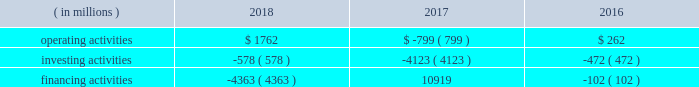Bhge 2018 form 10-k | 39 outstanding under the commercial paper program .
The maximum combined borrowing at any time under both the 2017 credit agreement and the commercial paper program is $ 3 billion .
If market conditions were to change and our revenue was reduced significantly or operating costs were to increase , our cash flows and liquidity could be reduced .
Additionally , it could cause the rating agencies to lower our credit rating .
There are no ratings triggers that would accelerate the maturity of any borrowings under our committed credit facility .
However , a downgrade in our credit ratings could increase the cost of borrowings under the credit facility and could also limit or preclude our ability to issue commercial paper .
Should this occur , we could seek alternative sources of funding , including borrowing under the credit facility .
During the year ended december 31 , 2018 , we used cash to fund a variety of activities including certain working capital needs and restructuring costs , capital expenditures , the repayment of debt , payment of dividends , distributions to ge and share repurchases .
We believe that cash on hand , cash flows generated from operations and the available credit facility will provide sufficient liquidity to manage our global cash needs .
Cash flows cash flows provided by ( used in ) each type of activity were as follows for the years ended december 31: .
Operating activities our largest source of operating cash is payments from customers , of which the largest component is collecting cash related to product or services sales including advance payments or progress collections for work to be performed .
The primary use of operating cash is to pay our suppliers , employees , tax authorities and others for a wide range of material and services .
Cash flows from operating activities generated cash of $ 1762 million and used cash of $ 799 million for the years ended december 31 , 2018 and 2017 , respectively .
Cash flows from operating activities increased $ 2561 million in 2018 primarily driven by better operating performance .
These cash inflows were supported by strong working capital cash flows , especially in the fourth quarter of 2018 , including approximately $ 300 million for a progress collection payment from a customer .
Included in our cash flows from operating activities for 2018 and 2017 are payments of $ 473 million and $ 612 million , respectively , made primarily for employee severance as a result of our restructuring activities and merger and related costs .
Cash flows from operating activities used $ 799 million and generated $ 262 million for the years ended december 31 , 2017 and 2016 , respectively .
Cash flows from operating activities decreased $ 1061 million in 2017 primarily driven by a $ 1201 million negative impact from ending our receivables monetization program in the fourth quarter , and restructuring related payments throughout the year .
These cash outflows were partially offset by strong working capital cash flows , especially in the fourth quarter of 2017 .
Included in our cash flows from operating activities for 2017 and 2016 are payments of $ 612 million and $ 177 million , respectively , made for employee severance as a result of our restructuring activities and merger and related costs .
Investing activities cash flows from investing activities used cash of $ 578 million , $ 4123 million and $ 472 million for the years ended december 31 , 2018 , 2017 and 2016 , respectively .
Our principal recurring investing activity is the funding of capital expenditures to ensure that we have the appropriate levels and types of machinery and equipment in place to generate revenue from operations .
Expenditures for capital assets totaled $ 995 million , $ 665 million and $ 424 million for 2018 , 2017 and 2016 , respectively , partially offset by cash flows from the sale of property , plant and equipment of $ 458 million , $ 172 million and $ 20 million in 2018 , 2017 and 2016 , respectively .
Proceeds from the disposal of assets related primarily .
What are the cash flows from the sale of property , plant and equipment in 2018 as a percentage of cash from operating activities in 2018? 
Computations: (458 / 1762)
Answer: 0.25993. 